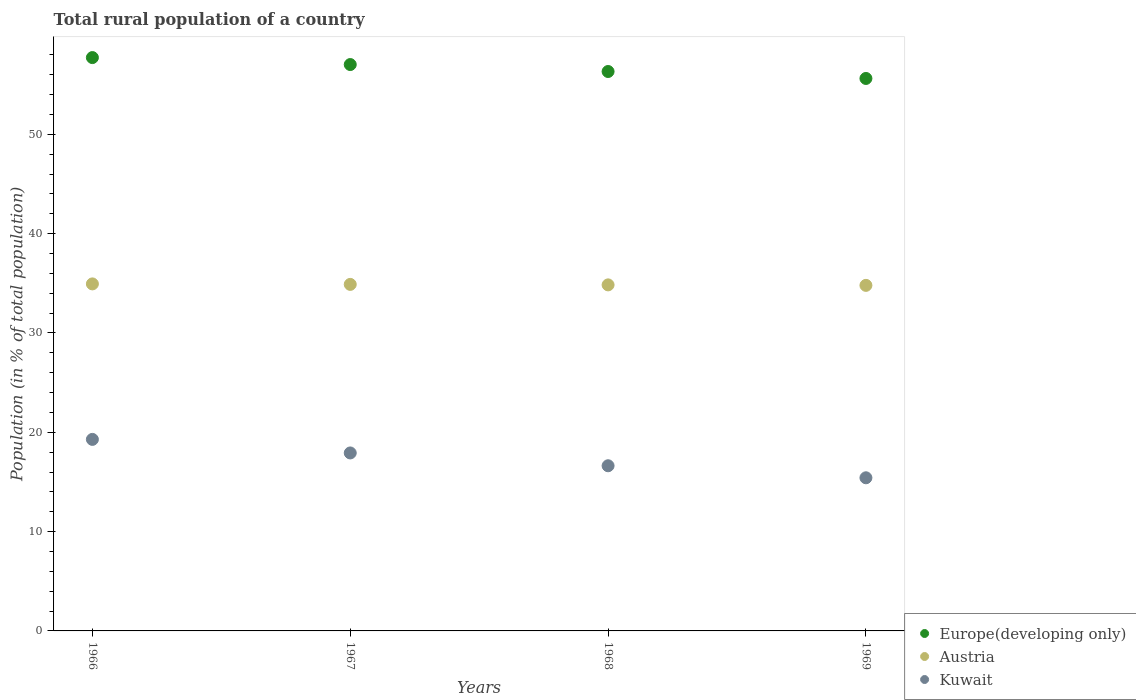What is the rural population in Europe(developing only) in 1967?
Make the answer very short. 57.02. Across all years, what is the maximum rural population in Austria?
Give a very brief answer. 34.94. Across all years, what is the minimum rural population in Kuwait?
Give a very brief answer. 15.42. In which year was the rural population in Austria maximum?
Offer a terse response. 1966. In which year was the rural population in Europe(developing only) minimum?
Keep it short and to the point. 1969. What is the total rural population in Kuwait in the graph?
Your response must be concise. 69.25. What is the difference between the rural population in Kuwait in 1966 and that in 1968?
Ensure brevity in your answer.  2.65. What is the difference between the rural population in Austria in 1966 and the rural population in Kuwait in 1968?
Ensure brevity in your answer.  18.31. What is the average rural population in Europe(developing only) per year?
Offer a terse response. 56.67. In the year 1966, what is the difference between the rural population in Austria and rural population in Kuwait?
Keep it short and to the point. 15.66. In how many years, is the rural population in Kuwait greater than 46 %?
Keep it short and to the point. 0. What is the ratio of the rural population in Kuwait in 1966 to that in 1968?
Your answer should be compact. 1.16. Is the difference between the rural population in Austria in 1967 and 1968 greater than the difference between the rural population in Kuwait in 1967 and 1968?
Keep it short and to the point. No. What is the difference between the highest and the second highest rural population in Europe(developing only)?
Your answer should be very brief. 0.7. What is the difference between the highest and the lowest rural population in Austria?
Ensure brevity in your answer.  0.15. In how many years, is the rural population in Austria greater than the average rural population in Austria taken over all years?
Offer a terse response. 2. Does the rural population in Kuwait monotonically increase over the years?
Your answer should be compact. No. Is the rural population in Austria strictly greater than the rural population in Kuwait over the years?
Make the answer very short. Yes. Is the rural population in Kuwait strictly less than the rural population in Austria over the years?
Your answer should be very brief. Yes. How many years are there in the graph?
Your answer should be compact. 4. Does the graph contain grids?
Offer a terse response. No. What is the title of the graph?
Provide a short and direct response. Total rural population of a country. Does "Ecuador" appear as one of the legend labels in the graph?
Provide a short and direct response. No. What is the label or title of the Y-axis?
Your answer should be very brief. Population (in % of total population). What is the Population (in % of total population) in Europe(developing only) in 1966?
Your answer should be very brief. 57.73. What is the Population (in % of total population) in Austria in 1966?
Provide a short and direct response. 34.94. What is the Population (in % of total population) of Kuwait in 1966?
Provide a short and direct response. 19.28. What is the Population (in % of total population) in Europe(developing only) in 1967?
Make the answer very short. 57.02. What is the Population (in % of total population) of Austria in 1967?
Make the answer very short. 34.89. What is the Population (in % of total population) of Kuwait in 1967?
Provide a short and direct response. 17.92. What is the Population (in % of total population) of Europe(developing only) in 1968?
Keep it short and to the point. 56.32. What is the Population (in % of total population) of Austria in 1968?
Your answer should be compact. 34.84. What is the Population (in % of total population) of Kuwait in 1968?
Provide a succinct answer. 16.63. What is the Population (in % of total population) of Europe(developing only) in 1969?
Provide a short and direct response. 55.62. What is the Population (in % of total population) of Austria in 1969?
Provide a short and direct response. 34.79. What is the Population (in % of total population) of Kuwait in 1969?
Your response must be concise. 15.42. Across all years, what is the maximum Population (in % of total population) of Europe(developing only)?
Your answer should be very brief. 57.73. Across all years, what is the maximum Population (in % of total population) of Austria?
Your response must be concise. 34.94. Across all years, what is the maximum Population (in % of total population) in Kuwait?
Make the answer very short. 19.28. Across all years, what is the minimum Population (in % of total population) in Europe(developing only)?
Give a very brief answer. 55.62. Across all years, what is the minimum Population (in % of total population) in Austria?
Provide a short and direct response. 34.79. Across all years, what is the minimum Population (in % of total population) in Kuwait?
Your response must be concise. 15.42. What is the total Population (in % of total population) of Europe(developing only) in the graph?
Give a very brief answer. 226.7. What is the total Population (in % of total population) of Austria in the graph?
Offer a terse response. 139.46. What is the total Population (in % of total population) in Kuwait in the graph?
Your response must be concise. 69.25. What is the difference between the Population (in % of total population) of Europe(developing only) in 1966 and that in 1967?
Offer a very short reply. 0.7. What is the difference between the Population (in % of total population) of Austria in 1966 and that in 1967?
Provide a succinct answer. 0.05. What is the difference between the Population (in % of total population) in Kuwait in 1966 and that in 1967?
Ensure brevity in your answer.  1.36. What is the difference between the Population (in % of total population) in Europe(developing only) in 1966 and that in 1968?
Offer a terse response. 1.4. What is the difference between the Population (in % of total population) in Austria in 1966 and that in 1968?
Offer a very short reply. 0.1. What is the difference between the Population (in % of total population) of Kuwait in 1966 and that in 1968?
Ensure brevity in your answer.  2.65. What is the difference between the Population (in % of total population) of Europe(developing only) in 1966 and that in 1969?
Offer a terse response. 2.1. What is the difference between the Population (in % of total population) in Austria in 1966 and that in 1969?
Offer a very short reply. 0.15. What is the difference between the Population (in % of total population) of Kuwait in 1966 and that in 1969?
Offer a very short reply. 3.87. What is the difference between the Population (in % of total population) in Europe(developing only) in 1967 and that in 1968?
Provide a short and direct response. 0.7. What is the difference between the Population (in % of total population) in Austria in 1967 and that in 1968?
Provide a short and direct response. 0.05. What is the difference between the Population (in % of total population) in Kuwait in 1967 and that in 1968?
Offer a very short reply. 1.29. What is the difference between the Population (in % of total population) of Europe(developing only) in 1967 and that in 1969?
Provide a short and direct response. 1.4. What is the difference between the Population (in % of total population) in Austria in 1967 and that in 1969?
Keep it short and to the point. 0.1. What is the difference between the Population (in % of total population) of Kuwait in 1967 and that in 1969?
Keep it short and to the point. 2.5. What is the difference between the Population (in % of total population) of Europe(developing only) in 1968 and that in 1969?
Give a very brief answer. 0.7. What is the difference between the Population (in % of total population) of Austria in 1968 and that in 1969?
Offer a very short reply. 0.05. What is the difference between the Population (in % of total population) of Kuwait in 1968 and that in 1969?
Give a very brief answer. 1.21. What is the difference between the Population (in % of total population) in Europe(developing only) in 1966 and the Population (in % of total population) in Austria in 1967?
Provide a short and direct response. 22.84. What is the difference between the Population (in % of total population) of Europe(developing only) in 1966 and the Population (in % of total population) of Kuwait in 1967?
Your answer should be very brief. 39.81. What is the difference between the Population (in % of total population) of Austria in 1966 and the Population (in % of total population) of Kuwait in 1967?
Your answer should be very brief. 17.02. What is the difference between the Population (in % of total population) in Europe(developing only) in 1966 and the Population (in % of total population) in Austria in 1968?
Ensure brevity in your answer.  22.88. What is the difference between the Population (in % of total population) in Europe(developing only) in 1966 and the Population (in % of total population) in Kuwait in 1968?
Ensure brevity in your answer.  41.1. What is the difference between the Population (in % of total population) of Austria in 1966 and the Population (in % of total population) of Kuwait in 1968?
Your answer should be very brief. 18.31. What is the difference between the Population (in % of total population) of Europe(developing only) in 1966 and the Population (in % of total population) of Austria in 1969?
Provide a succinct answer. 22.93. What is the difference between the Population (in % of total population) in Europe(developing only) in 1966 and the Population (in % of total population) in Kuwait in 1969?
Provide a short and direct response. 42.31. What is the difference between the Population (in % of total population) in Austria in 1966 and the Population (in % of total population) in Kuwait in 1969?
Ensure brevity in your answer.  19.52. What is the difference between the Population (in % of total population) of Europe(developing only) in 1967 and the Population (in % of total population) of Austria in 1968?
Your answer should be very brief. 22.18. What is the difference between the Population (in % of total population) of Europe(developing only) in 1967 and the Population (in % of total population) of Kuwait in 1968?
Your answer should be very brief. 40.4. What is the difference between the Population (in % of total population) of Austria in 1967 and the Population (in % of total population) of Kuwait in 1968?
Offer a terse response. 18.26. What is the difference between the Population (in % of total population) of Europe(developing only) in 1967 and the Population (in % of total population) of Austria in 1969?
Provide a succinct answer. 22.23. What is the difference between the Population (in % of total population) of Europe(developing only) in 1967 and the Population (in % of total population) of Kuwait in 1969?
Offer a terse response. 41.61. What is the difference between the Population (in % of total population) of Austria in 1967 and the Population (in % of total population) of Kuwait in 1969?
Provide a succinct answer. 19.47. What is the difference between the Population (in % of total population) in Europe(developing only) in 1968 and the Population (in % of total population) in Austria in 1969?
Provide a short and direct response. 21.53. What is the difference between the Population (in % of total population) in Europe(developing only) in 1968 and the Population (in % of total population) in Kuwait in 1969?
Offer a very short reply. 40.91. What is the difference between the Population (in % of total population) in Austria in 1968 and the Population (in % of total population) in Kuwait in 1969?
Your response must be concise. 19.42. What is the average Population (in % of total population) of Europe(developing only) per year?
Your answer should be very brief. 56.67. What is the average Population (in % of total population) in Austria per year?
Provide a succinct answer. 34.87. What is the average Population (in % of total population) of Kuwait per year?
Keep it short and to the point. 17.31. In the year 1966, what is the difference between the Population (in % of total population) in Europe(developing only) and Population (in % of total population) in Austria?
Your answer should be compact. 22.79. In the year 1966, what is the difference between the Population (in % of total population) in Europe(developing only) and Population (in % of total population) in Kuwait?
Provide a short and direct response. 38.44. In the year 1966, what is the difference between the Population (in % of total population) in Austria and Population (in % of total population) in Kuwait?
Give a very brief answer. 15.65. In the year 1967, what is the difference between the Population (in % of total population) in Europe(developing only) and Population (in % of total population) in Austria?
Provide a succinct answer. 22.13. In the year 1967, what is the difference between the Population (in % of total population) of Europe(developing only) and Population (in % of total population) of Kuwait?
Give a very brief answer. 39.11. In the year 1967, what is the difference between the Population (in % of total population) of Austria and Population (in % of total population) of Kuwait?
Keep it short and to the point. 16.97. In the year 1968, what is the difference between the Population (in % of total population) in Europe(developing only) and Population (in % of total population) in Austria?
Provide a succinct answer. 21.48. In the year 1968, what is the difference between the Population (in % of total population) in Europe(developing only) and Population (in % of total population) in Kuwait?
Your answer should be compact. 39.69. In the year 1968, what is the difference between the Population (in % of total population) of Austria and Population (in % of total population) of Kuwait?
Provide a succinct answer. 18.21. In the year 1969, what is the difference between the Population (in % of total population) of Europe(developing only) and Population (in % of total population) of Austria?
Make the answer very short. 20.83. In the year 1969, what is the difference between the Population (in % of total population) in Europe(developing only) and Population (in % of total population) in Kuwait?
Make the answer very short. 40.21. In the year 1969, what is the difference between the Population (in % of total population) of Austria and Population (in % of total population) of Kuwait?
Offer a very short reply. 19.37. What is the ratio of the Population (in % of total population) in Europe(developing only) in 1966 to that in 1967?
Your response must be concise. 1.01. What is the ratio of the Population (in % of total population) of Austria in 1966 to that in 1967?
Provide a succinct answer. 1. What is the ratio of the Population (in % of total population) of Kuwait in 1966 to that in 1967?
Keep it short and to the point. 1.08. What is the ratio of the Population (in % of total population) in Europe(developing only) in 1966 to that in 1968?
Ensure brevity in your answer.  1.02. What is the ratio of the Population (in % of total population) of Austria in 1966 to that in 1968?
Make the answer very short. 1. What is the ratio of the Population (in % of total population) of Kuwait in 1966 to that in 1968?
Your answer should be compact. 1.16. What is the ratio of the Population (in % of total population) of Europe(developing only) in 1966 to that in 1969?
Your answer should be very brief. 1.04. What is the ratio of the Population (in % of total population) of Austria in 1966 to that in 1969?
Make the answer very short. 1. What is the ratio of the Population (in % of total population) in Kuwait in 1966 to that in 1969?
Give a very brief answer. 1.25. What is the ratio of the Population (in % of total population) of Europe(developing only) in 1967 to that in 1968?
Your answer should be very brief. 1.01. What is the ratio of the Population (in % of total population) of Austria in 1967 to that in 1968?
Offer a terse response. 1. What is the ratio of the Population (in % of total population) of Kuwait in 1967 to that in 1968?
Ensure brevity in your answer.  1.08. What is the ratio of the Population (in % of total population) of Europe(developing only) in 1967 to that in 1969?
Your answer should be compact. 1.03. What is the ratio of the Population (in % of total population) of Austria in 1967 to that in 1969?
Offer a terse response. 1. What is the ratio of the Population (in % of total population) in Kuwait in 1967 to that in 1969?
Your answer should be compact. 1.16. What is the ratio of the Population (in % of total population) of Europe(developing only) in 1968 to that in 1969?
Keep it short and to the point. 1.01. What is the ratio of the Population (in % of total population) of Austria in 1968 to that in 1969?
Offer a terse response. 1. What is the ratio of the Population (in % of total population) of Kuwait in 1968 to that in 1969?
Keep it short and to the point. 1.08. What is the difference between the highest and the second highest Population (in % of total population) in Europe(developing only)?
Your answer should be compact. 0.7. What is the difference between the highest and the second highest Population (in % of total population) in Austria?
Make the answer very short. 0.05. What is the difference between the highest and the second highest Population (in % of total population) in Kuwait?
Your answer should be compact. 1.36. What is the difference between the highest and the lowest Population (in % of total population) in Europe(developing only)?
Your response must be concise. 2.1. What is the difference between the highest and the lowest Population (in % of total population) in Austria?
Make the answer very short. 0.15. What is the difference between the highest and the lowest Population (in % of total population) in Kuwait?
Keep it short and to the point. 3.87. 